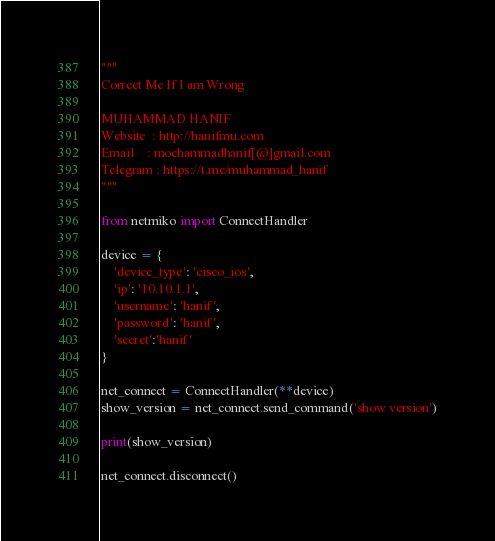Convert code to text. <code><loc_0><loc_0><loc_500><loc_500><_Python_>"""
Correct Me If I am Wrong

MUHAMMAD HANIF
Website  : http://hanifmu.com
Email    : moehammadhanif[@]gmail.com
Telegram : https://t.me/muhammad_hanif
"""

from netmiko import ConnectHandler

device = {
    'device_type': 'cisco_ios',
    'ip': '10.10.1.1',
    'username': 'hanif',
    'password': 'hanif',
    'secret':'hanif'
}

net_connect = ConnectHandler(**device)
show_version = net_connect.send_command('show version')

print(show_version)

net_connect.disconnect()
</code> 